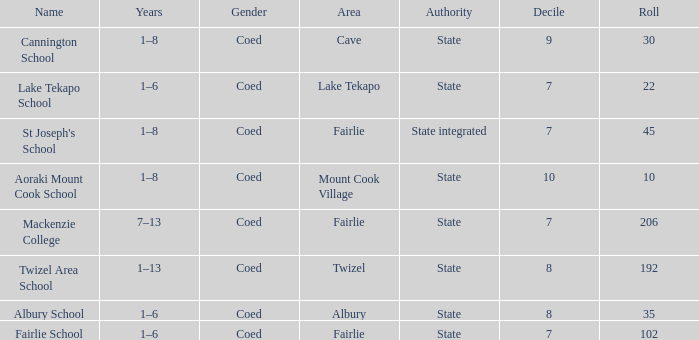What is the total Decile that has a state authority, fairlie area and roll smarter than 206? 1.0. 